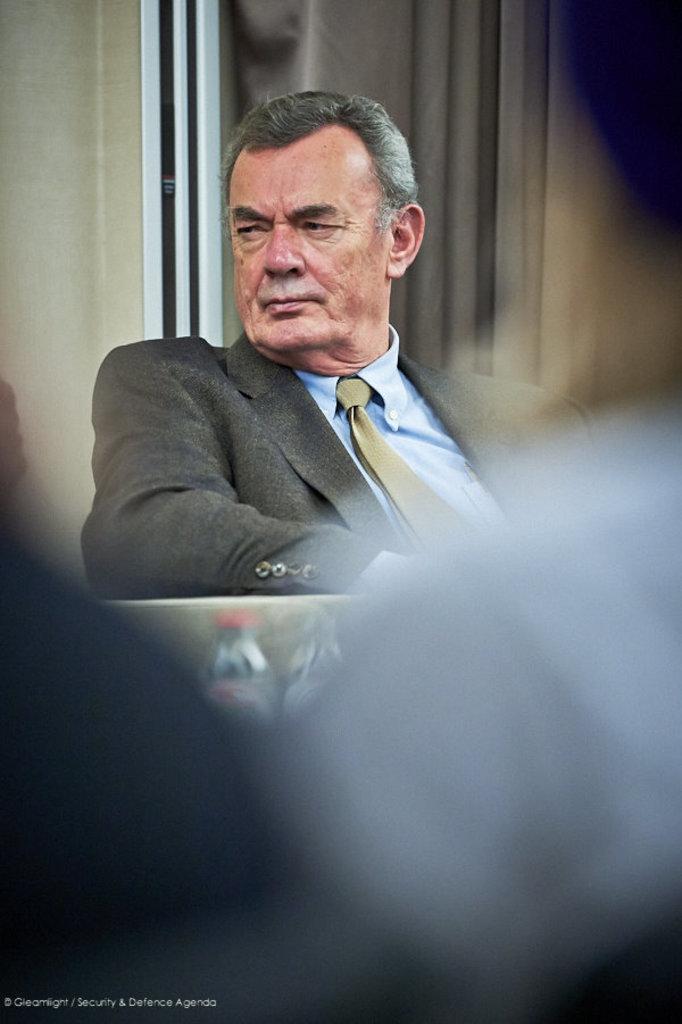Please provide a concise description of this image. In this image I can see a person sitting and the person is wearing gray color blazer, blue shirt and a tie. Background I can see the wall in cream color. 